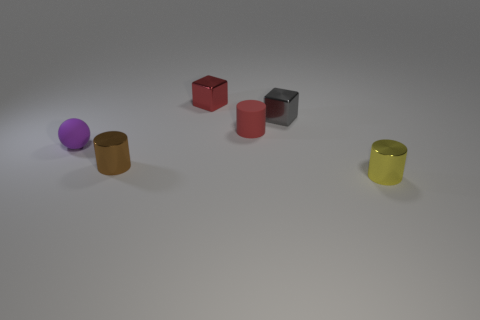The red object that is the same shape as the small brown object is what size?
Provide a short and direct response. Small. What number of small things have the same color as the small matte cylinder?
Offer a very short reply. 1. Is there a brown object of the same size as the yellow shiny thing?
Ensure brevity in your answer.  Yes. How many things are either small purple rubber things or tiny cyan matte cubes?
Provide a succinct answer. 1. Does the matte object that is on the left side of the red rubber cylinder have the same size as the metal cylinder on the left side of the yellow shiny cylinder?
Your response must be concise. Yes. Are there any other big yellow matte things that have the same shape as the yellow thing?
Provide a succinct answer. No. Are there fewer brown cylinders that are left of the purple rubber ball than brown matte things?
Provide a short and direct response. No. Is the small red shiny thing the same shape as the small purple rubber object?
Your answer should be very brief. No. What is the size of the red object that is behind the small gray block?
Give a very brief answer. Small. What size is the purple ball that is the same material as the red cylinder?
Make the answer very short. Small. 